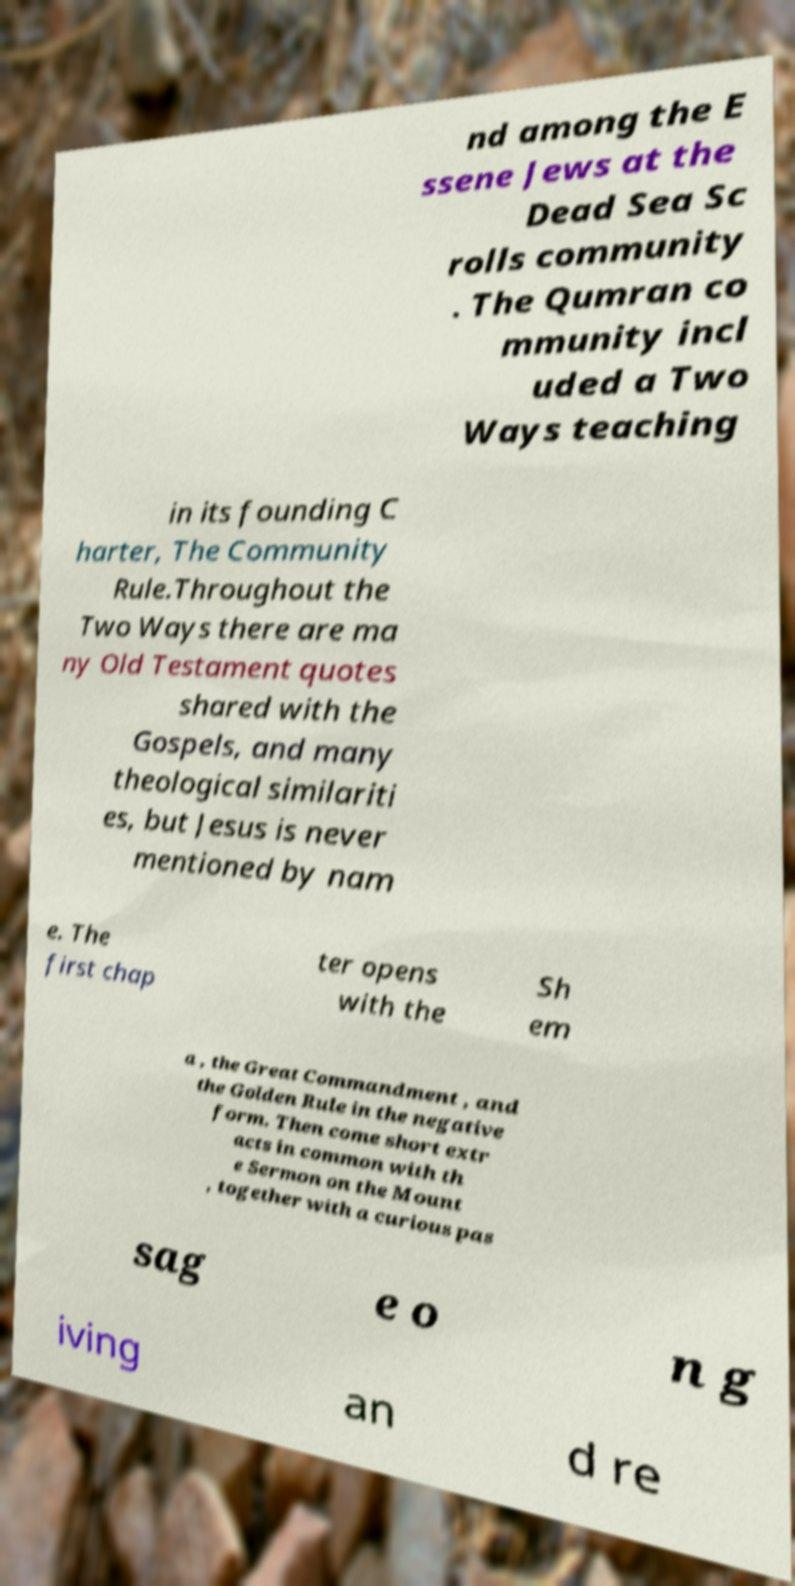Can you accurately transcribe the text from the provided image for me? nd among the E ssene Jews at the Dead Sea Sc rolls community . The Qumran co mmunity incl uded a Two Ways teaching in its founding C harter, The Community Rule.Throughout the Two Ways there are ma ny Old Testament quotes shared with the Gospels, and many theological similariti es, but Jesus is never mentioned by nam e. The first chap ter opens with the Sh em a , the Great Commandment , and the Golden Rule in the negative form. Then come short extr acts in common with th e Sermon on the Mount , together with a curious pas sag e o n g iving an d re 